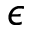<formula> <loc_0><loc_0><loc_500><loc_500>\epsilon</formula> 